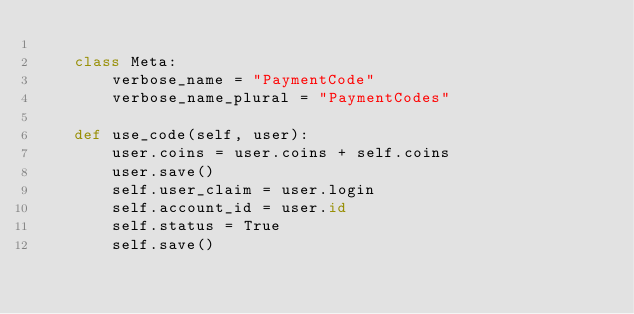<code> <loc_0><loc_0><loc_500><loc_500><_Python_>
    class Meta:
        verbose_name = "PaymentCode"
        verbose_name_plural = "PaymentCodes"

    def use_code(self, user):
        user.coins = user.coins + self.coins
        user.save()
        self.user_claim = user.login
        self.account_id = user.id
        self.status = True
        self.save()
</code> 